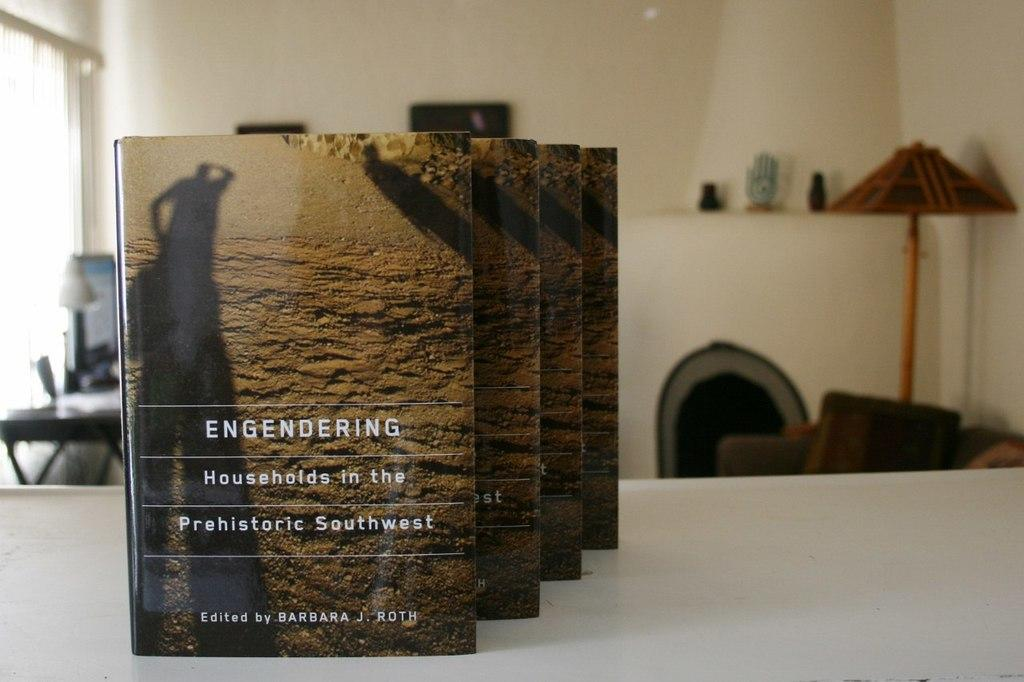What is on the table in the image? There are books on the table. What can be seen in the background of the image? There is a monitor, objects on the table, a wall, and additional unspecified things in the background. What type of stamp is on the son's forehead in the image? There is no son or stamp present in the image. 